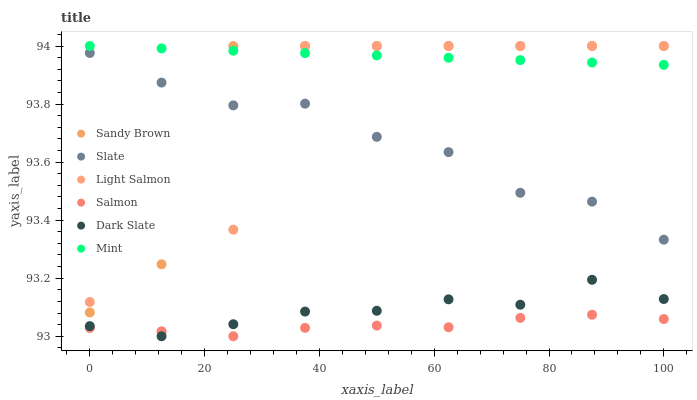Does Salmon have the minimum area under the curve?
Answer yes or no. Yes. Does Mint have the maximum area under the curve?
Answer yes or no. Yes. Does Sandy Brown have the minimum area under the curve?
Answer yes or no. No. Does Sandy Brown have the maximum area under the curve?
Answer yes or no. No. Is Mint the smoothest?
Answer yes or no. Yes. Is Light Salmon the roughest?
Answer yes or no. Yes. Is Sandy Brown the smoothest?
Answer yes or no. No. Is Sandy Brown the roughest?
Answer yes or no. No. Does Salmon have the lowest value?
Answer yes or no. Yes. Does Sandy Brown have the lowest value?
Answer yes or no. No. Does Mint have the highest value?
Answer yes or no. Yes. Does Slate have the highest value?
Answer yes or no. No. Is Salmon less than Light Salmon?
Answer yes or no. Yes. Is Mint greater than Dark Slate?
Answer yes or no. Yes. Does Salmon intersect Dark Slate?
Answer yes or no. Yes. Is Salmon less than Dark Slate?
Answer yes or no. No. Is Salmon greater than Dark Slate?
Answer yes or no. No. Does Salmon intersect Light Salmon?
Answer yes or no. No. 